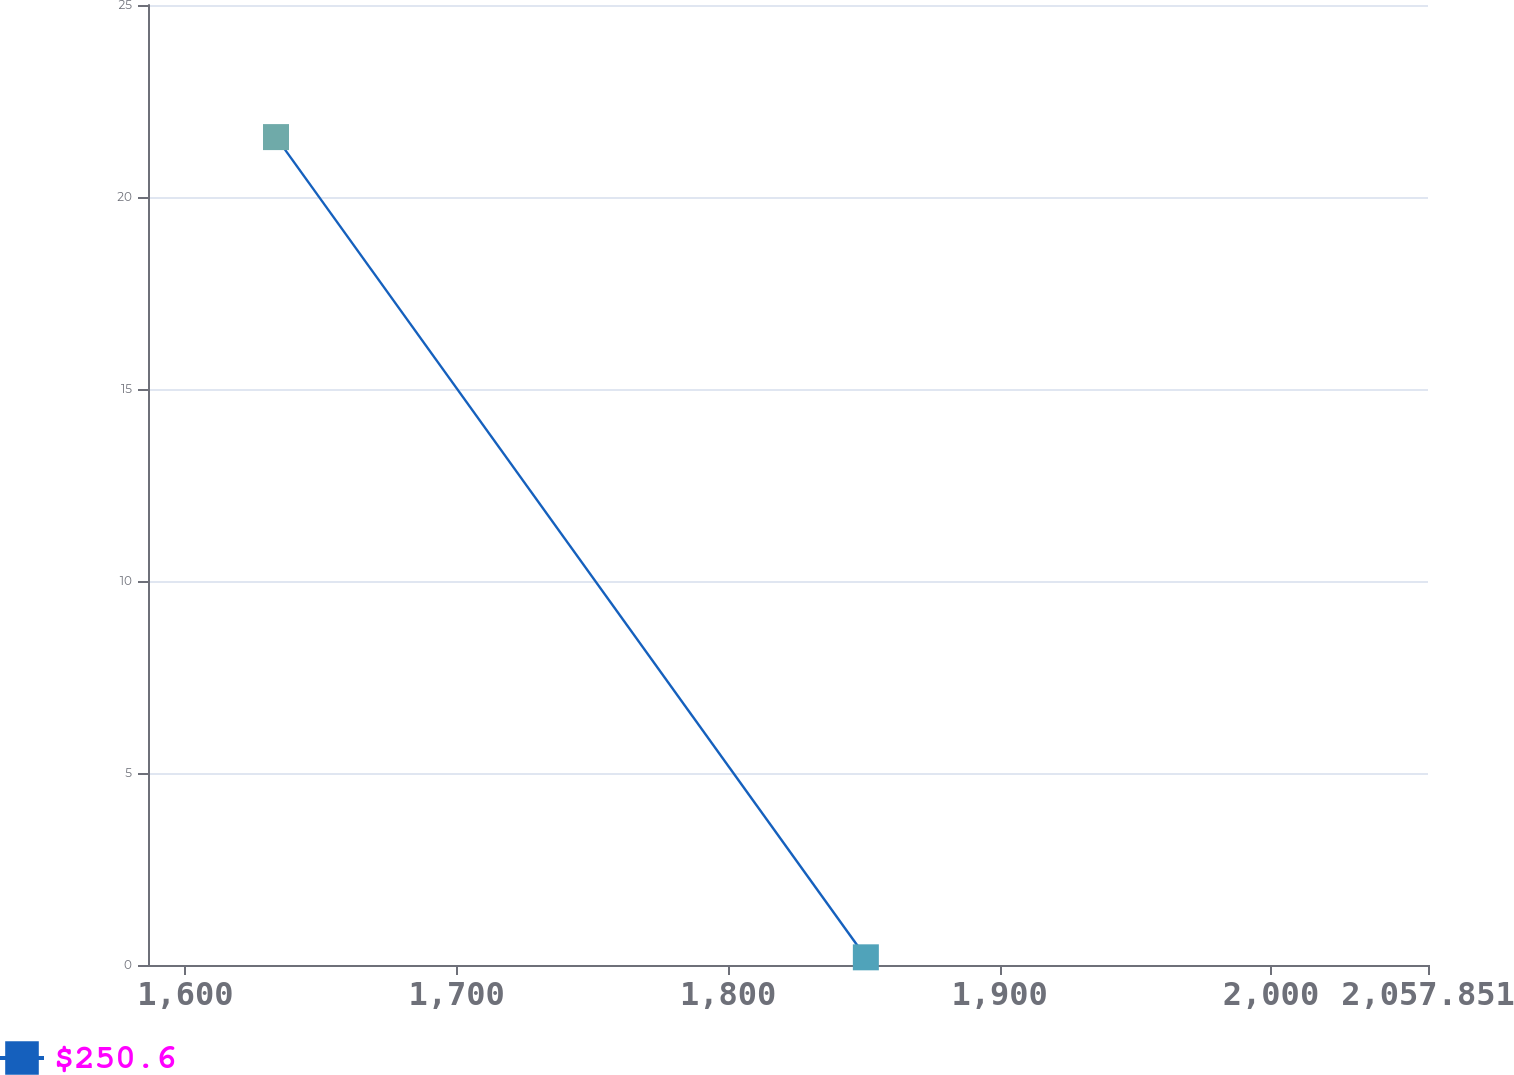Convert chart to OTSL. <chart><loc_0><loc_0><loc_500><loc_500><line_chart><ecel><fcel>$250.6<nl><fcel>1633.42<fcel>21.56<nl><fcel>1850.74<fcel>0.2<nl><fcel>2105.01<fcel>213.83<nl></chart> 